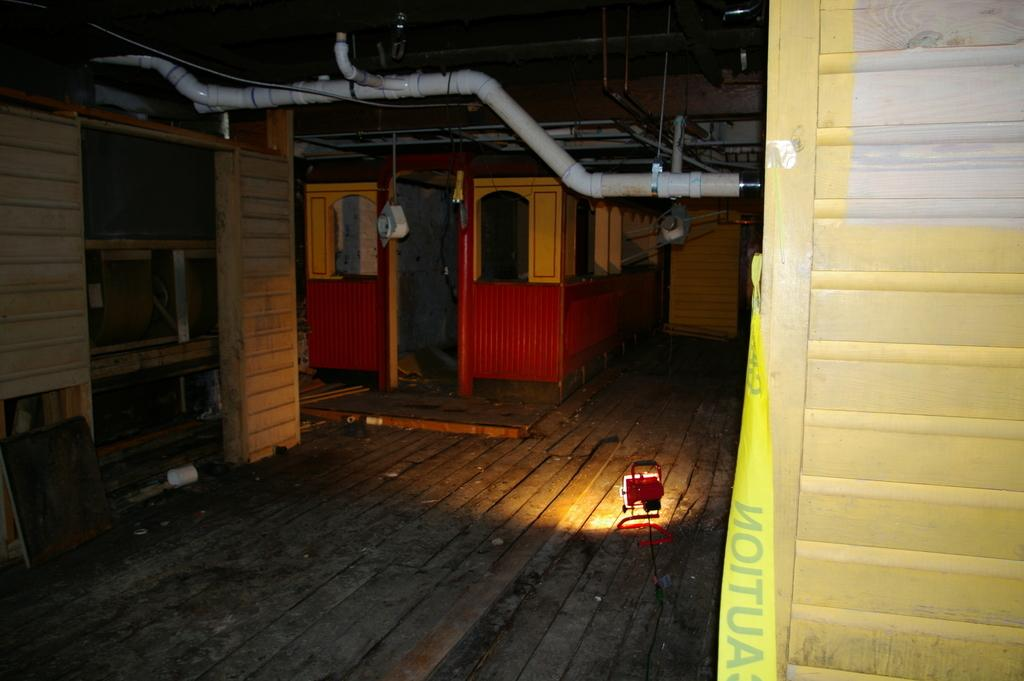What can be seen in the image that provides light? There is a light in the image. What is on the floor in the image? There are objects on the floor in the image. Can you describe any specific type of objects on the floor? There are wooden objects among the objects on the floor. How does the grape contribute to the overall design of the image? There is no grape present in the image, so it does not contribute to the overall design. 